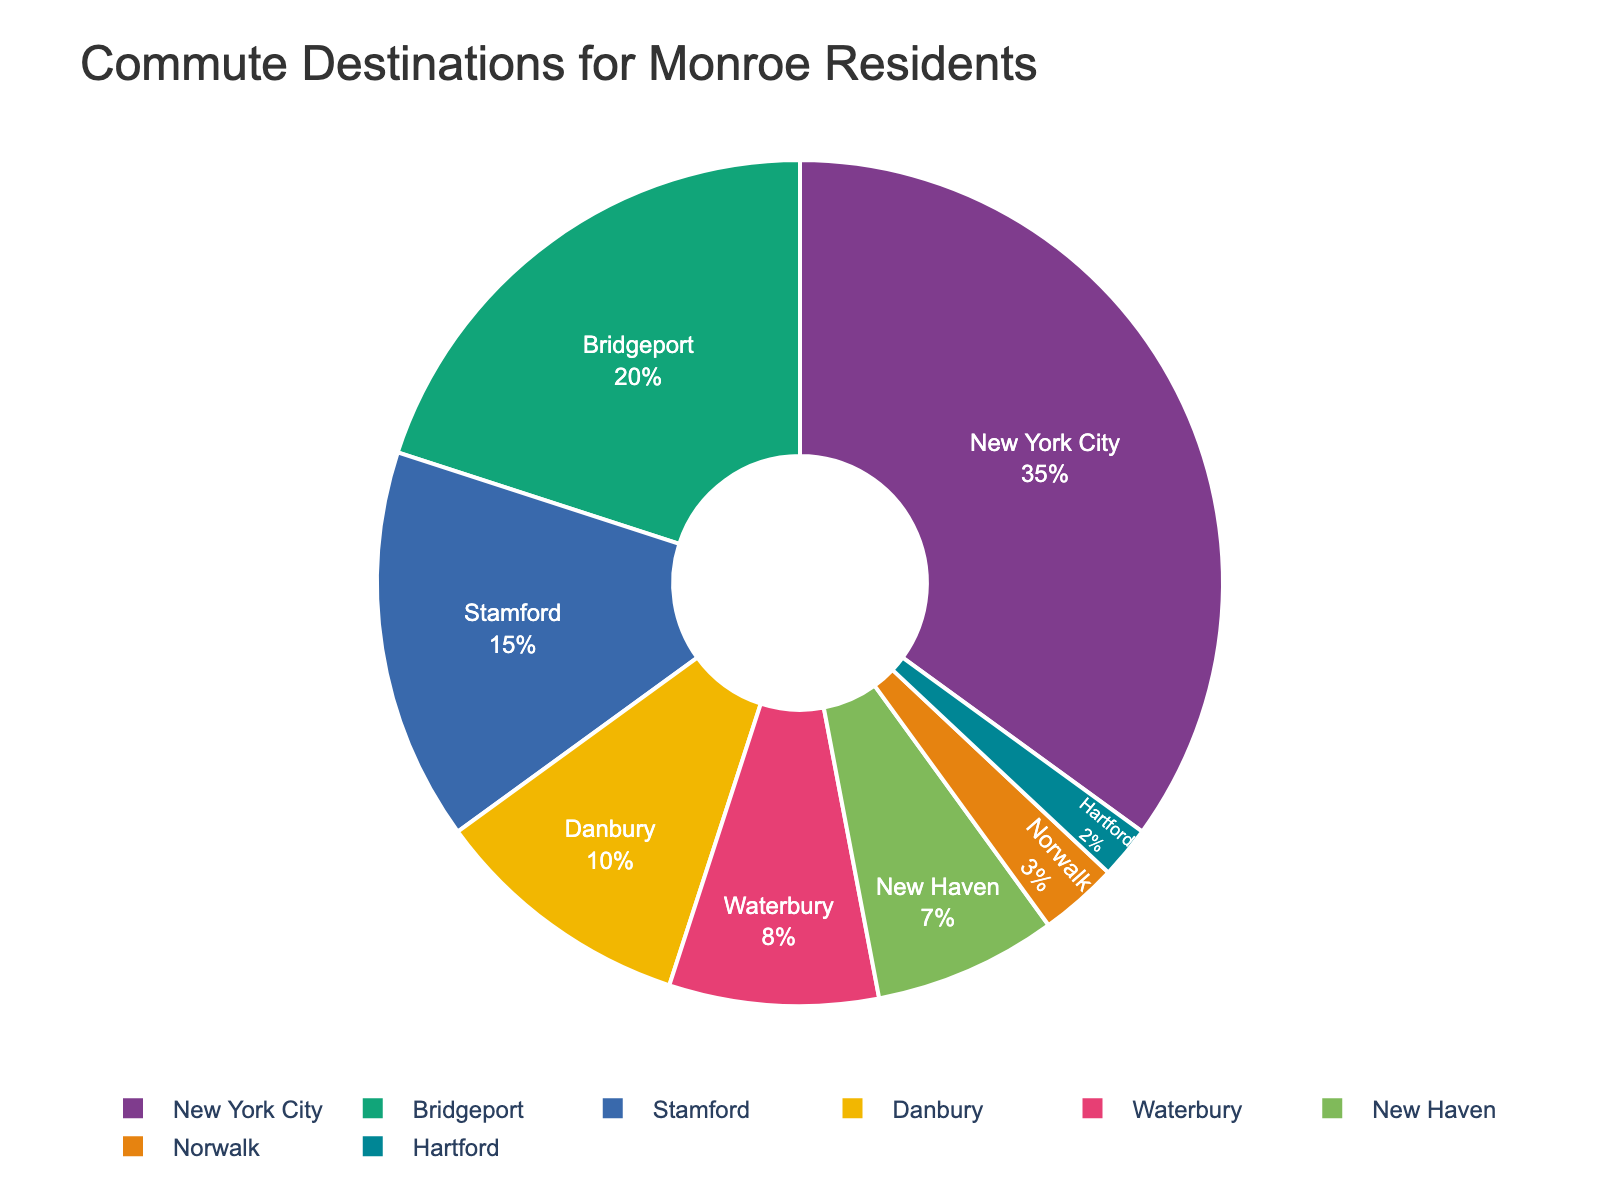Which city has the highest percentage of Monroe residents commuting to it? By looking at the pie chart, identify the city segment that occupies the largest portion. This city will have the highest percentage of commuters.
Answer: New York City What is the combined percentage of residents commuting to Bridgeport and Stamford? Add the percentages of commuters to Bridgeport (20%) and Stamford (15%). The combined percentage is 20 + 15.
Answer: 35% Which city has a higher percentage of commuters, Danbury or Waterbury? Compare the sizes of the pie slices for Danbury (10%) and Waterbury (8%). Danbury's slice is larger.
Answer: Danbury How much higher is the percentage of commuters to New York City than to Hartford? Subtract the percentage of commuters to Hartford (2%) from the percentage to New York City (35%). The difference is 35 - 2.
Answer: 33% What is the percentage difference between the city with the highest commute percentage and the city with the lowest? Identify the highest (New York City, 35%) and the lowest (Hartford, 2%) percentages. Subtract the smallest from the largest: 35 - 2.
Answer: 33% Are there more residents commuting to New Haven or to Norwalk? Compare the percentages for New Haven (7%) and Norwalk (3%). New Haven has a higher percentage.
Answer: New Haven What is the total percentage of residents commuting to the top three cities? Sum the percentages of the top three cities: New York City (35%), Bridgeport (20%), and Stamford (15%). The total is 35 + 20 + 15.
Answer: 70% Which city has a pie slice with a distinct pastel color? Look at the pie chart and identify the specific pastel color, matching it with the corresponding city label.
Answer: Varies based on the chart (e.g., could be Norwalk or another city) What is the average percentage of residents commuting to all cities represented in the pie chart? Add the percentages of commuters to all cities and divide by the number of cities: (35 + 20 + 15 + 10 + 8 + 7 + 3 + 2) / 8.
Answer: 12.5% Between Stamford and Waterbury, which city has the lower percentage of Monroe commuters? Compare the percentages for Stamford (15%) and Waterbury (8%). Waterbury has the lower percentage.
Answer: Waterbury 